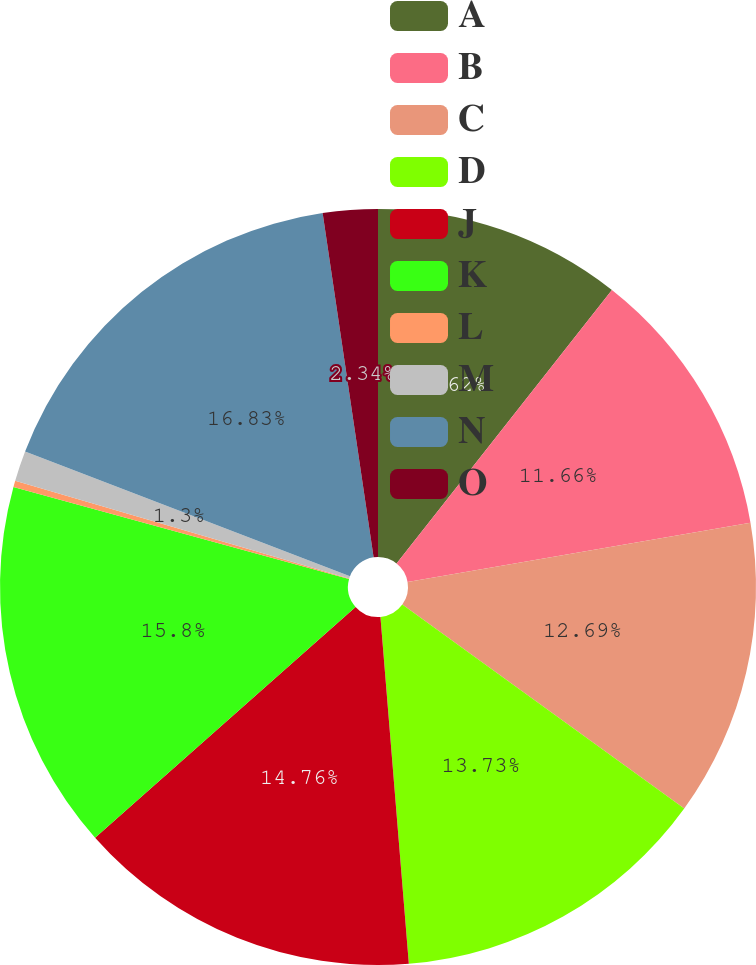Convert chart. <chart><loc_0><loc_0><loc_500><loc_500><pie_chart><fcel>A<fcel>B<fcel>C<fcel>D<fcel>J<fcel>K<fcel>L<fcel>M<fcel>N<fcel>O<nl><fcel>10.62%<fcel>11.66%<fcel>12.69%<fcel>13.73%<fcel>14.76%<fcel>15.8%<fcel>0.27%<fcel>1.3%<fcel>16.83%<fcel>2.34%<nl></chart> 